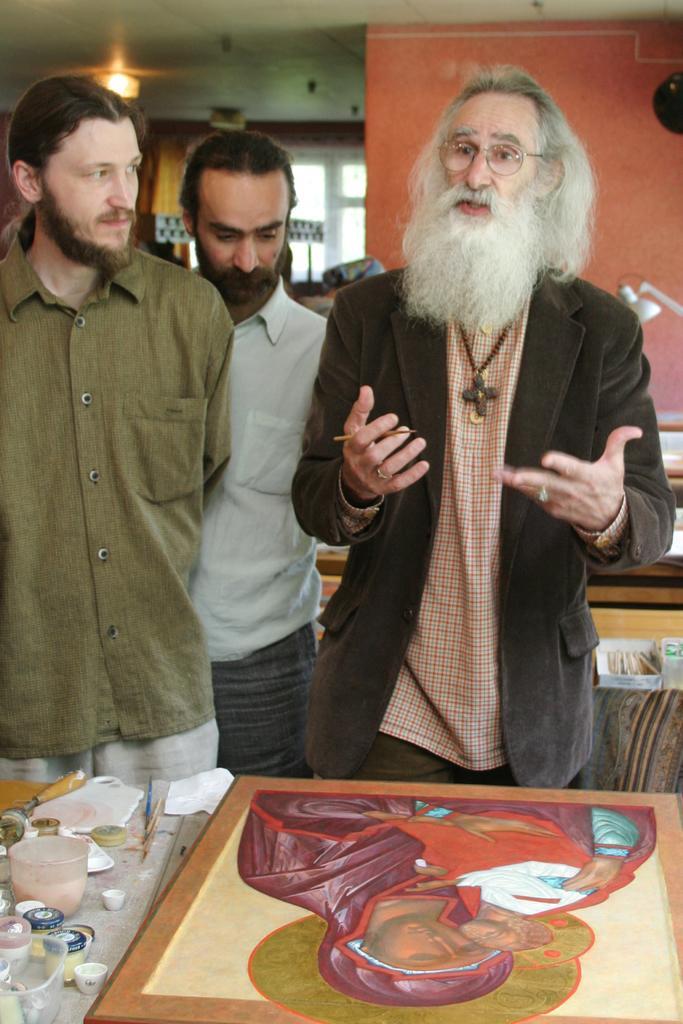Please provide a concise description of this image. In this image I can see a few people standing, painting and few objects on the table, behind there is a lamp, window, ceiling with lights. 